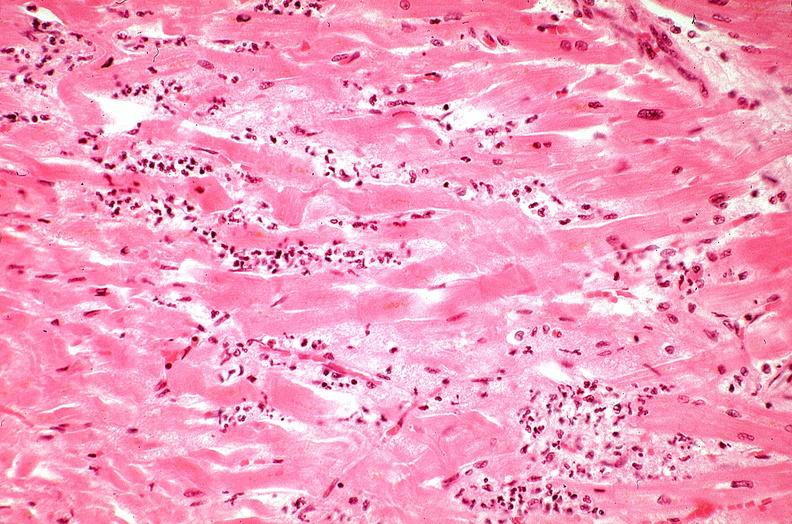does heart show heart, myocardial infarction, wavey fiber change, necrtosis, hemorrhage, and dissection?
Answer the question using a single word or phrase. No 